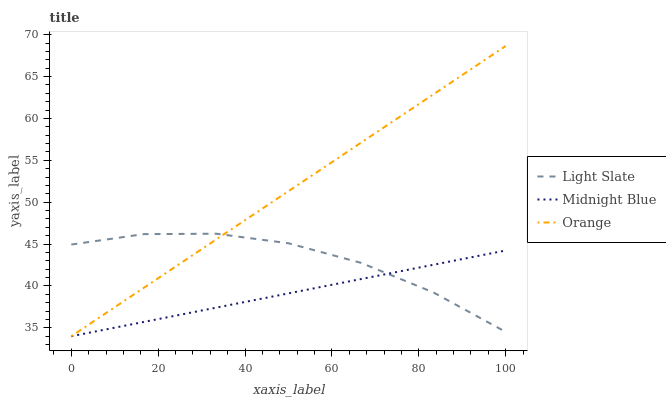Does Midnight Blue have the minimum area under the curve?
Answer yes or no. Yes. Does Orange have the maximum area under the curve?
Answer yes or no. Yes. Does Orange have the minimum area under the curve?
Answer yes or no. No. Does Midnight Blue have the maximum area under the curve?
Answer yes or no. No. Is Midnight Blue the smoothest?
Answer yes or no. Yes. Is Light Slate the roughest?
Answer yes or no. Yes. Is Orange the smoothest?
Answer yes or no. No. Is Orange the roughest?
Answer yes or no. No. Does Orange have the lowest value?
Answer yes or no. Yes. Does Orange have the highest value?
Answer yes or no. Yes. Does Midnight Blue have the highest value?
Answer yes or no. No. Does Light Slate intersect Orange?
Answer yes or no. Yes. Is Light Slate less than Orange?
Answer yes or no. No. Is Light Slate greater than Orange?
Answer yes or no. No. 